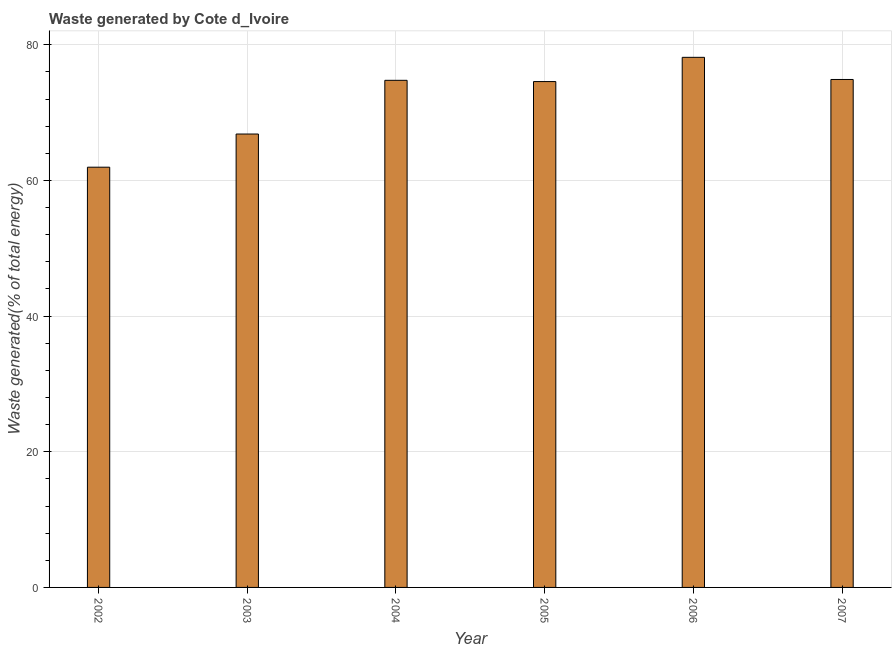Does the graph contain grids?
Offer a terse response. Yes. What is the title of the graph?
Give a very brief answer. Waste generated by Cote d_Ivoire. What is the label or title of the X-axis?
Your answer should be compact. Year. What is the label or title of the Y-axis?
Offer a terse response. Waste generated(% of total energy). What is the amount of waste generated in 2002?
Ensure brevity in your answer.  61.95. Across all years, what is the maximum amount of waste generated?
Ensure brevity in your answer.  78.15. Across all years, what is the minimum amount of waste generated?
Ensure brevity in your answer.  61.95. In which year was the amount of waste generated minimum?
Provide a short and direct response. 2002. What is the sum of the amount of waste generated?
Your answer should be compact. 431.15. What is the difference between the amount of waste generated in 2003 and 2004?
Ensure brevity in your answer.  -7.92. What is the average amount of waste generated per year?
Provide a short and direct response. 71.86. What is the median amount of waste generated?
Your response must be concise. 74.66. In how many years, is the amount of waste generated greater than 20 %?
Give a very brief answer. 6. What is the ratio of the amount of waste generated in 2003 to that in 2004?
Make the answer very short. 0.89. Is the amount of waste generated in 2004 less than that in 2006?
Give a very brief answer. Yes. What is the difference between the highest and the second highest amount of waste generated?
Provide a succinct answer. 3.27. Is the sum of the amount of waste generated in 2003 and 2004 greater than the maximum amount of waste generated across all years?
Give a very brief answer. Yes. In how many years, is the amount of waste generated greater than the average amount of waste generated taken over all years?
Provide a short and direct response. 4. How many bars are there?
Ensure brevity in your answer.  6. What is the Waste generated(% of total energy) of 2002?
Your answer should be compact. 61.95. What is the Waste generated(% of total energy) in 2003?
Provide a succinct answer. 66.84. What is the Waste generated(% of total energy) of 2004?
Your response must be concise. 74.76. What is the Waste generated(% of total energy) of 2005?
Provide a short and direct response. 74.57. What is the Waste generated(% of total energy) in 2006?
Ensure brevity in your answer.  78.15. What is the Waste generated(% of total energy) of 2007?
Provide a short and direct response. 74.88. What is the difference between the Waste generated(% of total energy) in 2002 and 2003?
Make the answer very short. -4.89. What is the difference between the Waste generated(% of total energy) in 2002 and 2004?
Keep it short and to the point. -12.81. What is the difference between the Waste generated(% of total energy) in 2002 and 2005?
Keep it short and to the point. -12.62. What is the difference between the Waste generated(% of total energy) in 2002 and 2006?
Make the answer very short. -16.2. What is the difference between the Waste generated(% of total energy) in 2002 and 2007?
Offer a terse response. -12.93. What is the difference between the Waste generated(% of total energy) in 2003 and 2004?
Keep it short and to the point. -7.92. What is the difference between the Waste generated(% of total energy) in 2003 and 2005?
Your response must be concise. -7.73. What is the difference between the Waste generated(% of total energy) in 2003 and 2006?
Your response must be concise. -11.31. What is the difference between the Waste generated(% of total energy) in 2003 and 2007?
Offer a terse response. -8.04. What is the difference between the Waste generated(% of total energy) in 2004 and 2005?
Ensure brevity in your answer.  0.18. What is the difference between the Waste generated(% of total energy) in 2004 and 2006?
Give a very brief answer. -3.39. What is the difference between the Waste generated(% of total energy) in 2004 and 2007?
Keep it short and to the point. -0.12. What is the difference between the Waste generated(% of total energy) in 2005 and 2006?
Offer a terse response. -3.57. What is the difference between the Waste generated(% of total energy) in 2005 and 2007?
Provide a short and direct response. -0.31. What is the difference between the Waste generated(% of total energy) in 2006 and 2007?
Make the answer very short. 3.27. What is the ratio of the Waste generated(% of total energy) in 2002 to that in 2003?
Ensure brevity in your answer.  0.93. What is the ratio of the Waste generated(% of total energy) in 2002 to that in 2004?
Keep it short and to the point. 0.83. What is the ratio of the Waste generated(% of total energy) in 2002 to that in 2005?
Keep it short and to the point. 0.83. What is the ratio of the Waste generated(% of total energy) in 2002 to that in 2006?
Provide a short and direct response. 0.79. What is the ratio of the Waste generated(% of total energy) in 2002 to that in 2007?
Offer a terse response. 0.83. What is the ratio of the Waste generated(% of total energy) in 2003 to that in 2004?
Provide a succinct answer. 0.89. What is the ratio of the Waste generated(% of total energy) in 2003 to that in 2005?
Provide a short and direct response. 0.9. What is the ratio of the Waste generated(% of total energy) in 2003 to that in 2006?
Ensure brevity in your answer.  0.85. What is the ratio of the Waste generated(% of total energy) in 2003 to that in 2007?
Ensure brevity in your answer.  0.89. What is the ratio of the Waste generated(% of total energy) in 2004 to that in 2005?
Keep it short and to the point. 1. What is the ratio of the Waste generated(% of total energy) in 2004 to that in 2006?
Provide a short and direct response. 0.96. What is the ratio of the Waste generated(% of total energy) in 2005 to that in 2006?
Provide a succinct answer. 0.95. What is the ratio of the Waste generated(% of total energy) in 2006 to that in 2007?
Keep it short and to the point. 1.04. 